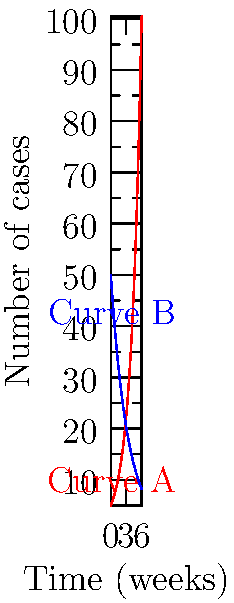Based on the epidemiological curves shown in the graph, which curve (A or B) represents a typical outbreak pattern for a highly contagious but controllable disease, and what phase of the outbreak is likely occurring at week 4? To interpret these epidemiological curves:

1. Analyze curve shapes:
   - Curve A: Exponential growth, increasing rapidly over time.
   - Curve B: Exponential decay, decreasing rapidly over time.

2. Identify typical outbreak patterns:
   - A contagious but controllable disease usually shows:
     a) Initial rapid increase (exponential growth)
     b) Peak
     c) Decline as control measures take effect

3. Match patterns to curves:
   - Curve A matches the initial growth phase of an outbreak.
   - Curve B represents the declining phase after control measures.

4. Consider the full outbreak cycle:
   - Curve B likely follows a peak that occurred before week 0.
   - The complete outbreak pattern would resemble Curve B.

5. Determine the phase at week 4:
   - On Curve B, week 4 is well into the declining phase.
   - This suggests control measures are effective.

Therefore, Curve B represents a typical outbreak pattern for a highly contagious but controllable disease, and at week 4, the outbreak is in the declining phase.
Answer: Curve B; Declining phase 